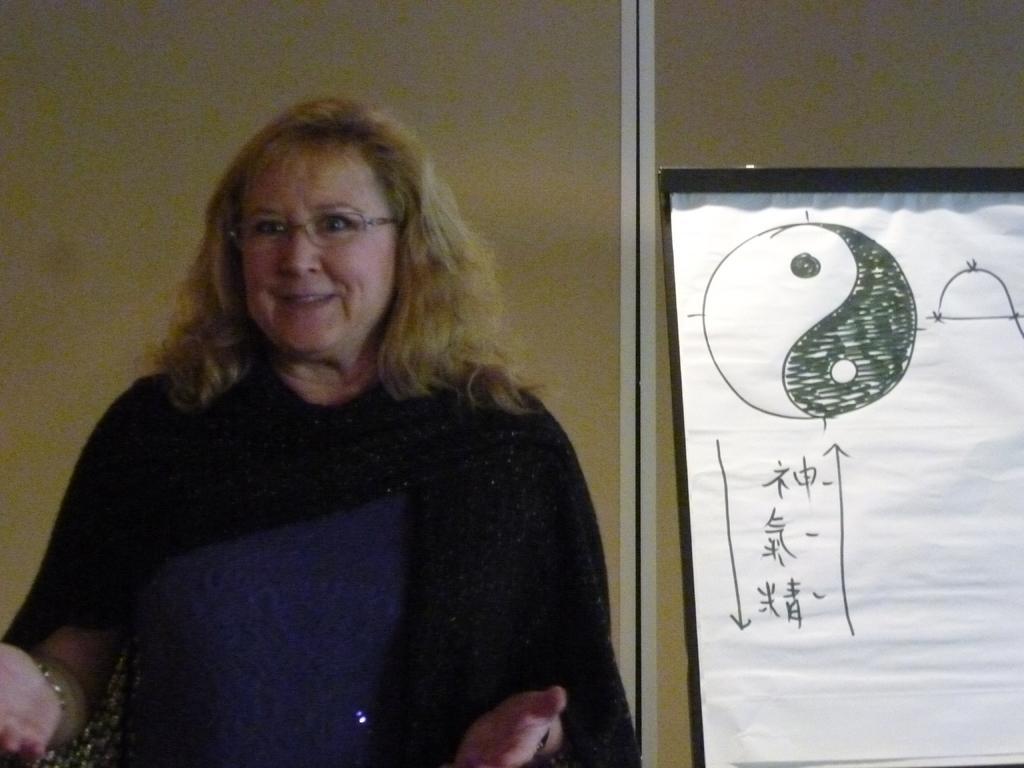Can you describe this image briefly? In this picture I can see there is a woman standing here and she is smiling and there is a board on the right side and there is a wall in the backdrop. 